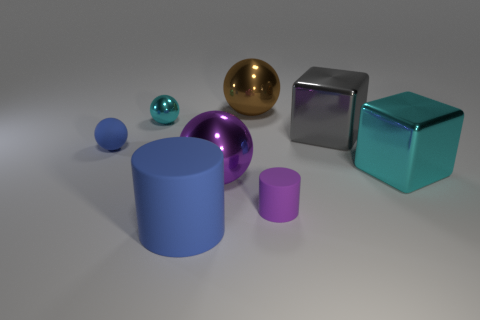Subtract all big brown metal spheres. How many spheres are left? 3 Add 2 small blue rubber cubes. How many objects exist? 10 Subtract all cyan cubes. How many cubes are left? 1 Subtract all cubes. How many objects are left? 6 Subtract all cyan cylinders. How many cyan cubes are left? 1 Add 6 large balls. How many large balls exist? 8 Subtract 1 cyan blocks. How many objects are left? 7 Subtract 1 cylinders. How many cylinders are left? 1 Subtract all red cubes. Subtract all red spheres. How many cubes are left? 2 Subtract all large brown cylinders. Subtract all blue matte cylinders. How many objects are left? 7 